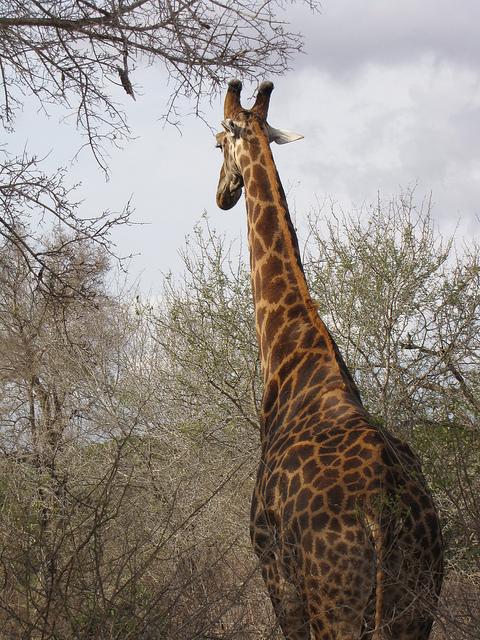How many giraffes are there?
Write a very short answer. 1. What kind of trees are there?
Keep it brief. Pine. Is the giraffe grazing?
Give a very brief answer. No. Is the animal looking at the camera?
Keep it brief. No. Is the giraffe full grown?
Be succinct. Yes. How many people in this photo?
Short answer required. 0. What color are the trees?
Concise answer only. Brown. Where is the giraffe?
Give a very brief answer. Africa. What is the animal eating?
Keep it brief. Leaves. Is this animal in the wild?
Answer briefly. Yes. 